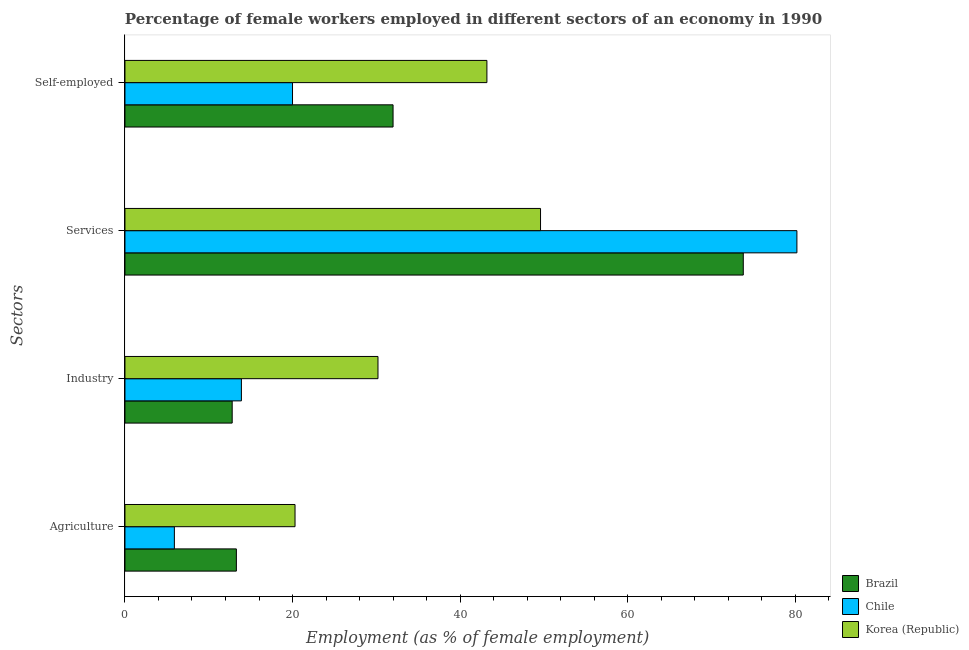How many groups of bars are there?
Provide a succinct answer. 4. Are the number of bars on each tick of the Y-axis equal?
Provide a succinct answer. Yes. What is the label of the 2nd group of bars from the top?
Ensure brevity in your answer.  Services. What is the percentage of female workers in services in Chile?
Provide a short and direct response. 80.2. Across all countries, what is the maximum percentage of self employed female workers?
Offer a very short reply. 43.2. Across all countries, what is the minimum percentage of self employed female workers?
Offer a terse response. 20. In which country was the percentage of self employed female workers minimum?
Your answer should be compact. Chile. What is the total percentage of self employed female workers in the graph?
Provide a short and direct response. 95.2. What is the difference between the percentage of female workers in industry in Brazil and the percentage of female workers in services in Korea (Republic)?
Offer a very short reply. -36.8. What is the average percentage of self employed female workers per country?
Make the answer very short. 31.73. What is the difference between the percentage of female workers in industry and percentage of female workers in services in Chile?
Provide a short and direct response. -66.3. In how many countries, is the percentage of female workers in agriculture greater than 44 %?
Offer a terse response. 0. What is the ratio of the percentage of female workers in services in Korea (Republic) to that in Brazil?
Make the answer very short. 0.67. Is the difference between the percentage of female workers in services in Chile and Brazil greater than the difference between the percentage of female workers in industry in Chile and Brazil?
Provide a short and direct response. Yes. What is the difference between the highest and the second highest percentage of self employed female workers?
Give a very brief answer. 11.2. What is the difference between the highest and the lowest percentage of female workers in services?
Provide a short and direct response. 30.6. Is the sum of the percentage of self employed female workers in Chile and Korea (Republic) greater than the maximum percentage of female workers in agriculture across all countries?
Keep it short and to the point. Yes. Is it the case that in every country, the sum of the percentage of female workers in agriculture and percentage of female workers in industry is greater than the sum of percentage of female workers in services and percentage of self employed female workers?
Your response must be concise. No. What does the 3rd bar from the bottom in Self-employed represents?
Provide a short and direct response. Korea (Republic). Is it the case that in every country, the sum of the percentage of female workers in agriculture and percentage of female workers in industry is greater than the percentage of female workers in services?
Provide a succinct answer. No. What is the difference between two consecutive major ticks on the X-axis?
Provide a succinct answer. 20. Does the graph contain any zero values?
Make the answer very short. No. Does the graph contain grids?
Your response must be concise. No. How many legend labels are there?
Your response must be concise. 3. What is the title of the graph?
Ensure brevity in your answer.  Percentage of female workers employed in different sectors of an economy in 1990. What is the label or title of the X-axis?
Give a very brief answer. Employment (as % of female employment). What is the label or title of the Y-axis?
Offer a very short reply. Sectors. What is the Employment (as % of female employment) in Brazil in Agriculture?
Keep it short and to the point. 13.3. What is the Employment (as % of female employment) in Chile in Agriculture?
Your answer should be very brief. 5.9. What is the Employment (as % of female employment) in Korea (Republic) in Agriculture?
Provide a succinct answer. 20.3. What is the Employment (as % of female employment) of Brazil in Industry?
Your answer should be very brief. 12.8. What is the Employment (as % of female employment) of Chile in Industry?
Ensure brevity in your answer.  13.9. What is the Employment (as % of female employment) of Korea (Republic) in Industry?
Offer a very short reply. 30.2. What is the Employment (as % of female employment) of Brazil in Services?
Your answer should be very brief. 73.8. What is the Employment (as % of female employment) in Chile in Services?
Provide a succinct answer. 80.2. What is the Employment (as % of female employment) of Korea (Republic) in Services?
Your answer should be compact. 49.6. What is the Employment (as % of female employment) of Brazil in Self-employed?
Offer a very short reply. 32. What is the Employment (as % of female employment) in Korea (Republic) in Self-employed?
Make the answer very short. 43.2. Across all Sectors, what is the maximum Employment (as % of female employment) of Brazil?
Your response must be concise. 73.8. Across all Sectors, what is the maximum Employment (as % of female employment) of Chile?
Provide a succinct answer. 80.2. Across all Sectors, what is the maximum Employment (as % of female employment) of Korea (Republic)?
Keep it short and to the point. 49.6. Across all Sectors, what is the minimum Employment (as % of female employment) of Brazil?
Keep it short and to the point. 12.8. Across all Sectors, what is the minimum Employment (as % of female employment) in Chile?
Your answer should be very brief. 5.9. Across all Sectors, what is the minimum Employment (as % of female employment) of Korea (Republic)?
Give a very brief answer. 20.3. What is the total Employment (as % of female employment) of Brazil in the graph?
Your response must be concise. 131.9. What is the total Employment (as % of female employment) in Chile in the graph?
Your response must be concise. 120. What is the total Employment (as % of female employment) in Korea (Republic) in the graph?
Your answer should be compact. 143.3. What is the difference between the Employment (as % of female employment) of Brazil in Agriculture and that in Industry?
Your answer should be compact. 0.5. What is the difference between the Employment (as % of female employment) of Korea (Republic) in Agriculture and that in Industry?
Offer a very short reply. -9.9. What is the difference between the Employment (as % of female employment) of Brazil in Agriculture and that in Services?
Provide a succinct answer. -60.5. What is the difference between the Employment (as % of female employment) in Chile in Agriculture and that in Services?
Your answer should be compact. -74.3. What is the difference between the Employment (as % of female employment) of Korea (Republic) in Agriculture and that in Services?
Ensure brevity in your answer.  -29.3. What is the difference between the Employment (as % of female employment) in Brazil in Agriculture and that in Self-employed?
Your answer should be very brief. -18.7. What is the difference between the Employment (as % of female employment) of Chile in Agriculture and that in Self-employed?
Your answer should be compact. -14.1. What is the difference between the Employment (as % of female employment) in Korea (Republic) in Agriculture and that in Self-employed?
Keep it short and to the point. -22.9. What is the difference between the Employment (as % of female employment) of Brazil in Industry and that in Services?
Your response must be concise. -61. What is the difference between the Employment (as % of female employment) in Chile in Industry and that in Services?
Offer a terse response. -66.3. What is the difference between the Employment (as % of female employment) of Korea (Republic) in Industry and that in Services?
Give a very brief answer. -19.4. What is the difference between the Employment (as % of female employment) in Brazil in Industry and that in Self-employed?
Your answer should be compact. -19.2. What is the difference between the Employment (as % of female employment) of Chile in Industry and that in Self-employed?
Your response must be concise. -6.1. What is the difference between the Employment (as % of female employment) in Korea (Republic) in Industry and that in Self-employed?
Offer a terse response. -13. What is the difference between the Employment (as % of female employment) of Brazil in Services and that in Self-employed?
Give a very brief answer. 41.8. What is the difference between the Employment (as % of female employment) of Chile in Services and that in Self-employed?
Give a very brief answer. 60.2. What is the difference between the Employment (as % of female employment) in Korea (Republic) in Services and that in Self-employed?
Provide a short and direct response. 6.4. What is the difference between the Employment (as % of female employment) in Brazil in Agriculture and the Employment (as % of female employment) in Chile in Industry?
Your answer should be compact. -0.6. What is the difference between the Employment (as % of female employment) in Brazil in Agriculture and the Employment (as % of female employment) in Korea (Republic) in Industry?
Your answer should be compact. -16.9. What is the difference between the Employment (as % of female employment) of Chile in Agriculture and the Employment (as % of female employment) of Korea (Republic) in Industry?
Ensure brevity in your answer.  -24.3. What is the difference between the Employment (as % of female employment) of Brazil in Agriculture and the Employment (as % of female employment) of Chile in Services?
Provide a short and direct response. -66.9. What is the difference between the Employment (as % of female employment) in Brazil in Agriculture and the Employment (as % of female employment) in Korea (Republic) in Services?
Your answer should be compact. -36.3. What is the difference between the Employment (as % of female employment) of Chile in Agriculture and the Employment (as % of female employment) of Korea (Republic) in Services?
Your answer should be very brief. -43.7. What is the difference between the Employment (as % of female employment) of Brazil in Agriculture and the Employment (as % of female employment) of Korea (Republic) in Self-employed?
Keep it short and to the point. -29.9. What is the difference between the Employment (as % of female employment) of Chile in Agriculture and the Employment (as % of female employment) of Korea (Republic) in Self-employed?
Provide a short and direct response. -37.3. What is the difference between the Employment (as % of female employment) in Brazil in Industry and the Employment (as % of female employment) in Chile in Services?
Your response must be concise. -67.4. What is the difference between the Employment (as % of female employment) in Brazil in Industry and the Employment (as % of female employment) in Korea (Republic) in Services?
Offer a very short reply. -36.8. What is the difference between the Employment (as % of female employment) in Chile in Industry and the Employment (as % of female employment) in Korea (Republic) in Services?
Make the answer very short. -35.7. What is the difference between the Employment (as % of female employment) of Brazil in Industry and the Employment (as % of female employment) of Korea (Republic) in Self-employed?
Keep it short and to the point. -30.4. What is the difference between the Employment (as % of female employment) in Chile in Industry and the Employment (as % of female employment) in Korea (Republic) in Self-employed?
Ensure brevity in your answer.  -29.3. What is the difference between the Employment (as % of female employment) of Brazil in Services and the Employment (as % of female employment) of Chile in Self-employed?
Your answer should be compact. 53.8. What is the difference between the Employment (as % of female employment) of Brazil in Services and the Employment (as % of female employment) of Korea (Republic) in Self-employed?
Offer a terse response. 30.6. What is the difference between the Employment (as % of female employment) in Chile in Services and the Employment (as % of female employment) in Korea (Republic) in Self-employed?
Provide a short and direct response. 37. What is the average Employment (as % of female employment) of Brazil per Sectors?
Give a very brief answer. 32.98. What is the average Employment (as % of female employment) in Chile per Sectors?
Your response must be concise. 30. What is the average Employment (as % of female employment) of Korea (Republic) per Sectors?
Your answer should be very brief. 35.83. What is the difference between the Employment (as % of female employment) of Chile and Employment (as % of female employment) of Korea (Republic) in Agriculture?
Keep it short and to the point. -14.4. What is the difference between the Employment (as % of female employment) in Brazil and Employment (as % of female employment) in Chile in Industry?
Keep it short and to the point. -1.1. What is the difference between the Employment (as % of female employment) in Brazil and Employment (as % of female employment) in Korea (Republic) in Industry?
Provide a short and direct response. -17.4. What is the difference between the Employment (as % of female employment) of Chile and Employment (as % of female employment) of Korea (Republic) in Industry?
Your answer should be compact. -16.3. What is the difference between the Employment (as % of female employment) in Brazil and Employment (as % of female employment) in Korea (Republic) in Services?
Your answer should be compact. 24.2. What is the difference between the Employment (as % of female employment) of Chile and Employment (as % of female employment) of Korea (Republic) in Services?
Your answer should be very brief. 30.6. What is the difference between the Employment (as % of female employment) in Chile and Employment (as % of female employment) in Korea (Republic) in Self-employed?
Offer a very short reply. -23.2. What is the ratio of the Employment (as % of female employment) of Brazil in Agriculture to that in Industry?
Provide a short and direct response. 1.04. What is the ratio of the Employment (as % of female employment) of Chile in Agriculture to that in Industry?
Provide a short and direct response. 0.42. What is the ratio of the Employment (as % of female employment) of Korea (Republic) in Agriculture to that in Industry?
Provide a succinct answer. 0.67. What is the ratio of the Employment (as % of female employment) of Brazil in Agriculture to that in Services?
Provide a short and direct response. 0.18. What is the ratio of the Employment (as % of female employment) of Chile in Agriculture to that in Services?
Offer a very short reply. 0.07. What is the ratio of the Employment (as % of female employment) of Korea (Republic) in Agriculture to that in Services?
Provide a succinct answer. 0.41. What is the ratio of the Employment (as % of female employment) in Brazil in Agriculture to that in Self-employed?
Offer a terse response. 0.42. What is the ratio of the Employment (as % of female employment) in Chile in Agriculture to that in Self-employed?
Offer a terse response. 0.29. What is the ratio of the Employment (as % of female employment) in Korea (Republic) in Agriculture to that in Self-employed?
Give a very brief answer. 0.47. What is the ratio of the Employment (as % of female employment) in Brazil in Industry to that in Services?
Offer a terse response. 0.17. What is the ratio of the Employment (as % of female employment) in Chile in Industry to that in Services?
Provide a short and direct response. 0.17. What is the ratio of the Employment (as % of female employment) of Korea (Republic) in Industry to that in Services?
Your answer should be compact. 0.61. What is the ratio of the Employment (as % of female employment) in Brazil in Industry to that in Self-employed?
Keep it short and to the point. 0.4. What is the ratio of the Employment (as % of female employment) of Chile in Industry to that in Self-employed?
Provide a short and direct response. 0.69. What is the ratio of the Employment (as % of female employment) of Korea (Republic) in Industry to that in Self-employed?
Your response must be concise. 0.7. What is the ratio of the Employment (as % of female employment) in Brazil in Services to that in Self-employed?
Make the answer very short. 2.31. What is the ratio of the Employment (as % of female employment) of Chile in Services to that in Self-employed?
Make the answer very short. 4.01. What is the ratio of the Employment (as % of female employment) in Korea (Republic) in Services to that in Self-employed?
Ensure brevity in your answer.  1.15. What is the difference between the highest and the second highest Employment (as % of female employment) in Brazil?
Offer a very short reply. 41.8. What is the difference between the highest and the second highest Employment (as % of female employment) in Chile?
Your response must be concise. 60.2. What is the difference between the highest and the lowest Employment (as % of female employment) of Brazil?
Offer a very short reply. 61. What is the difference between the highest and the lowest Employment (as % of female employment) in Chile?
Offer a terse response. 74.3. What is the difference between the highest and the lowest Employment (as % of female employment) of Korea (Republic)?
Provide a short and direct response. 29.3. 